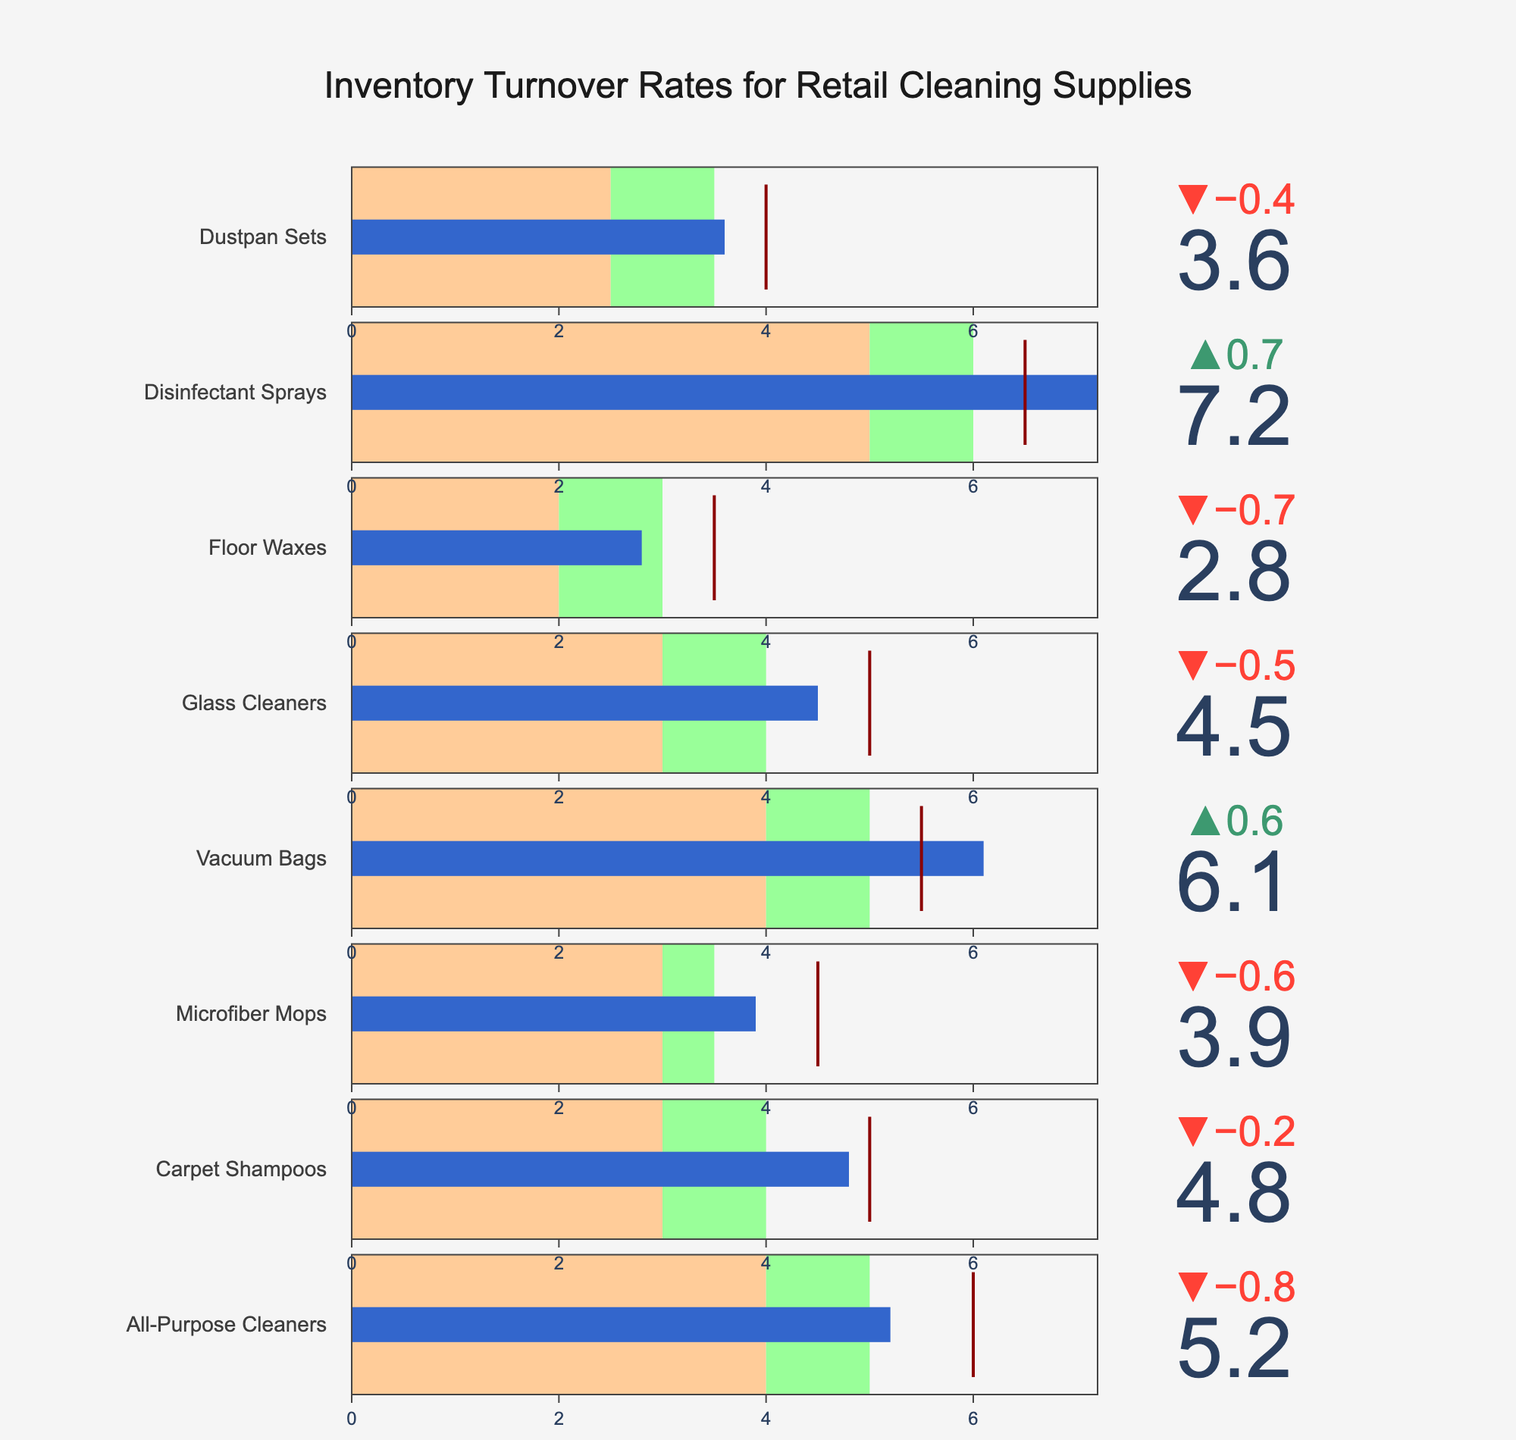Which category has the highest actual inventory turnover rate? Look at the lengths of the blue bars for each category. Disinfectant Sprays have the highest blue bar.
Answer: Disinfectant Sprays What is the actual inventory turnover rate for Carpet Shampoos? Find the blue bar corresponding to Carpet Shampoos and check its value.
Answer: 4.8 Which categories have actual turnover rates exceeding their target? Compare the blue bar and the red threshold line for each category. Vacuum Bags and Disinfectant Sprays have blue bars exceeding their red lines.
Answer: Vacuum Bags, Disinfectant Sprays Which category has the lowest target rate, and what is it? Check the red threshold lines for each category to find the lowest value. Floor Waxes have the lowest red line at 3.5.
Answer: Floor Waxes, 3.5 How many categories have actual turnover rates falling in the "Good" range? Look for blue bars within the green "Good" section. Vacuum Bags and Disinfectant Sprays fall in the Good range.
Answer: 2 Compare the actual turnover rates of All-Purpose Cleaners and Microfiber Mops. Which one is higher? Check the lengths of the blue bars for All-Purpose Cleaners and Microfiber Mops. All-Purpose Cleaners have a higher bar.
Answer: All-Purpose Cleaners What is the difference between the actual and target turnover rates for Glass Cleaners? Subtract the target value from the actual value for Glass Cleaners (4.5 - 5).
Answer: -0.5 Which categories have actual turnover rates in the "Poor" range? Look for blue bars within the red "Poor" section. None of the categories fall in the Poor range.
Answer: None What is the overall highest target inventory turnover rate, and which category is it for? Examine the red threshold lines and find the highest value. The highest is 6.5 for Disinfectant Sprays.
Answer: 6.5, Disinfectant Sprays 